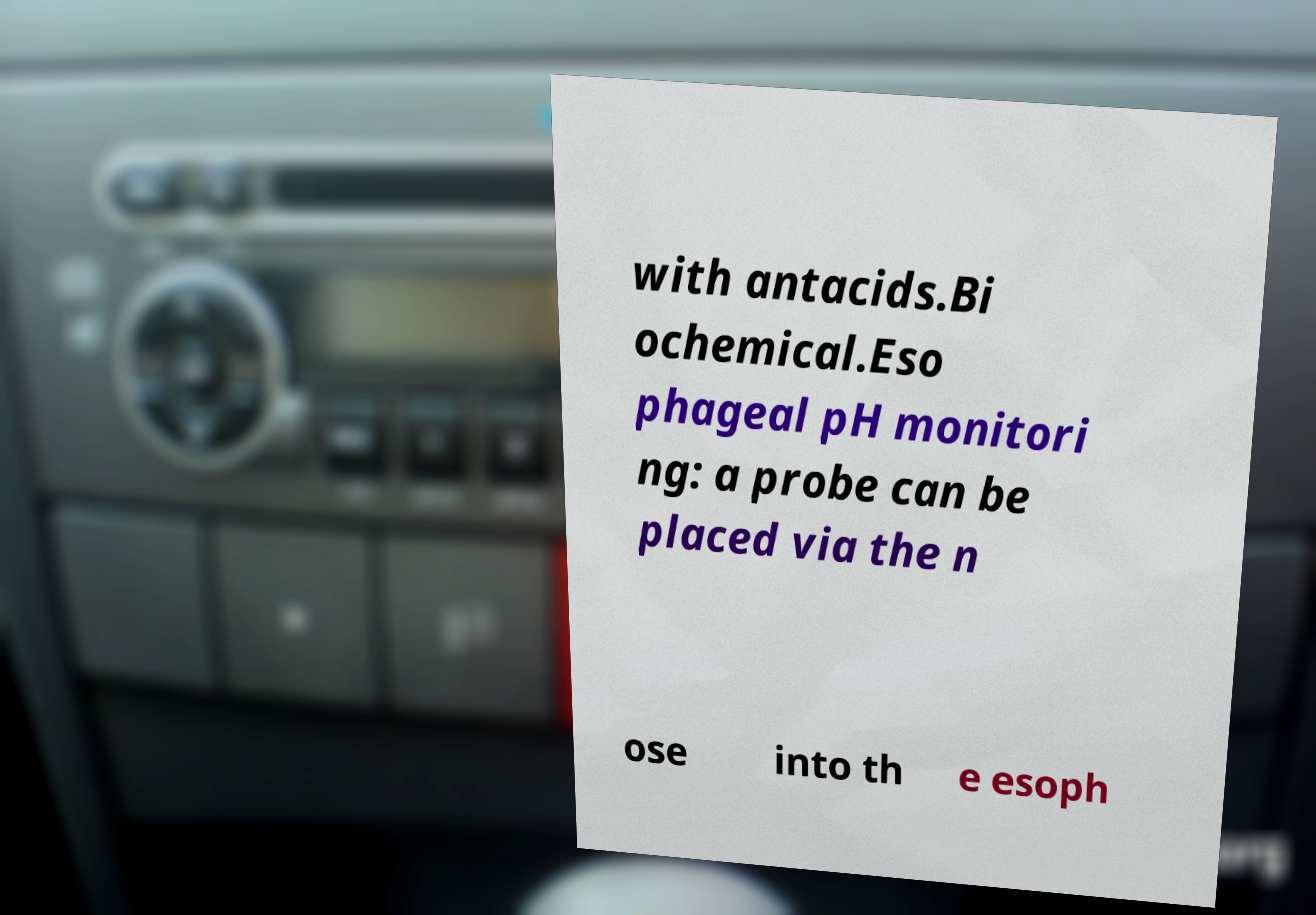Can you read and provide the text displayed in the image?This photo seems to have some interesting text. Can you extract and type it out for me? with antacids.Bi ochemical.Eso phageal pH monitori ng: a probe can be placed via the n ose into th e esoph 